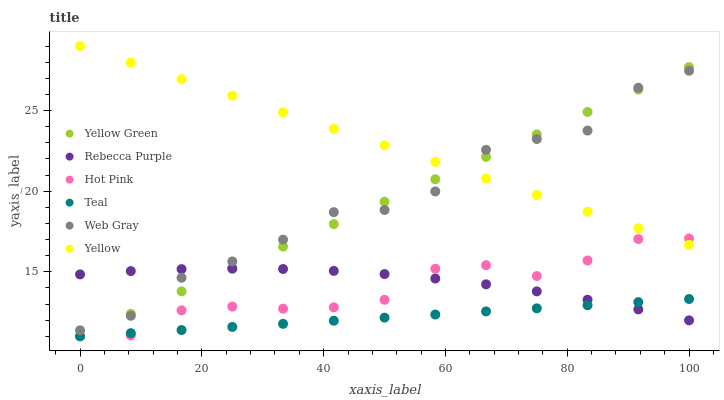Does Teal have the minimum area under the curve?
Answer yes or no. Yes. Does Yellow have the maximum area under the curve?
Answer yes or no. Yes. Does Yellow Green have the minimum area under the curve?
Answer yes or no. No. Does Yellow Green have the maximum area under the curve?
Answer yes or no. No. Is Teal the smoothest?
Answer yes or no. Yes. Is Web Gray the roughest?
Answer yes or no. Yes. Is Yellow Green the smoothest?
Answer yes or no. No. Is Yellow Green the roughest?
Answer yes or no. No. Does Yellow Green have the lowest value?
Answer yes or no. Yes. Does Yellow have the lowest value?
Answer yes or no. No. Does Yellow have the highest value?
Answer yes or no. Yes. Does Yellow Green have the highest value?
Answer yes or no. No. Is Teal less than Web Gray?
Answer yes or no. Yes. Is Web Gray greater than Teal?
Answer yes or no. Yes. Does Yellow Green intersect Web Gray?
Answer yes or no. Yes. Is Yellow Green less than Web Gray?
Answer yes or no. No. Is Yellow Green greater than Web Gray?
Answer yes or no. No. Does Teal intersect Web Gray?
Answer yes or no. No. 